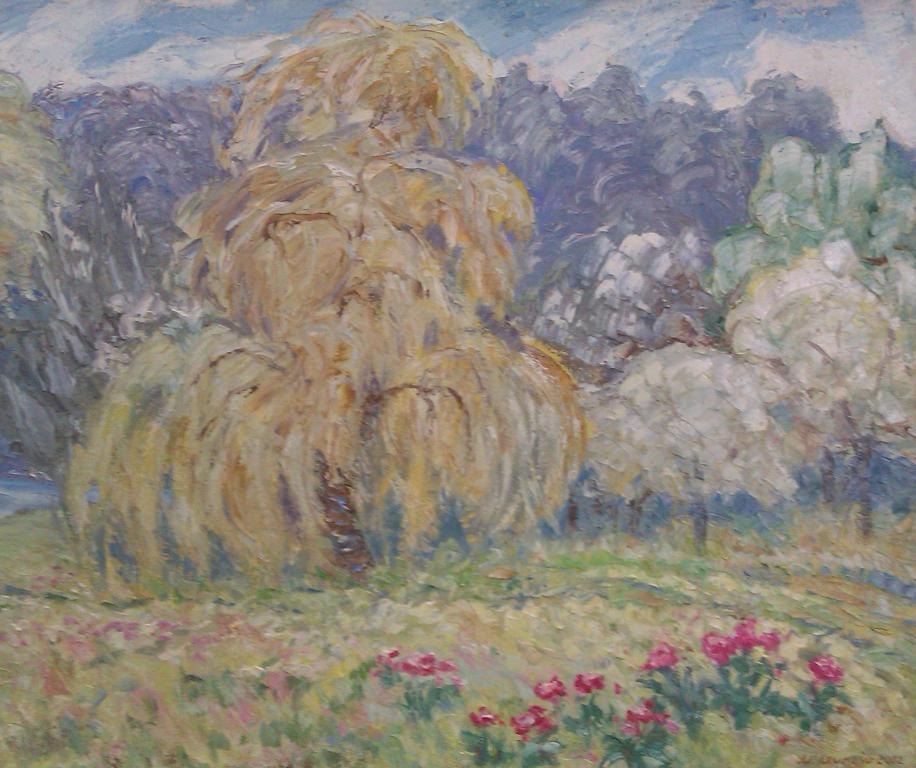What is the main subject of the image? The image contains a painting. What is depicted at the bottom of the painting? There are flower plants at the bottom of the painting. What can be seen in the background of the painting? There are trees visible in the background of the painting. What type of magic does the daughter perform in the painting? There is no daughter present in the painting, and therefore no magic or related activities can be observed. 